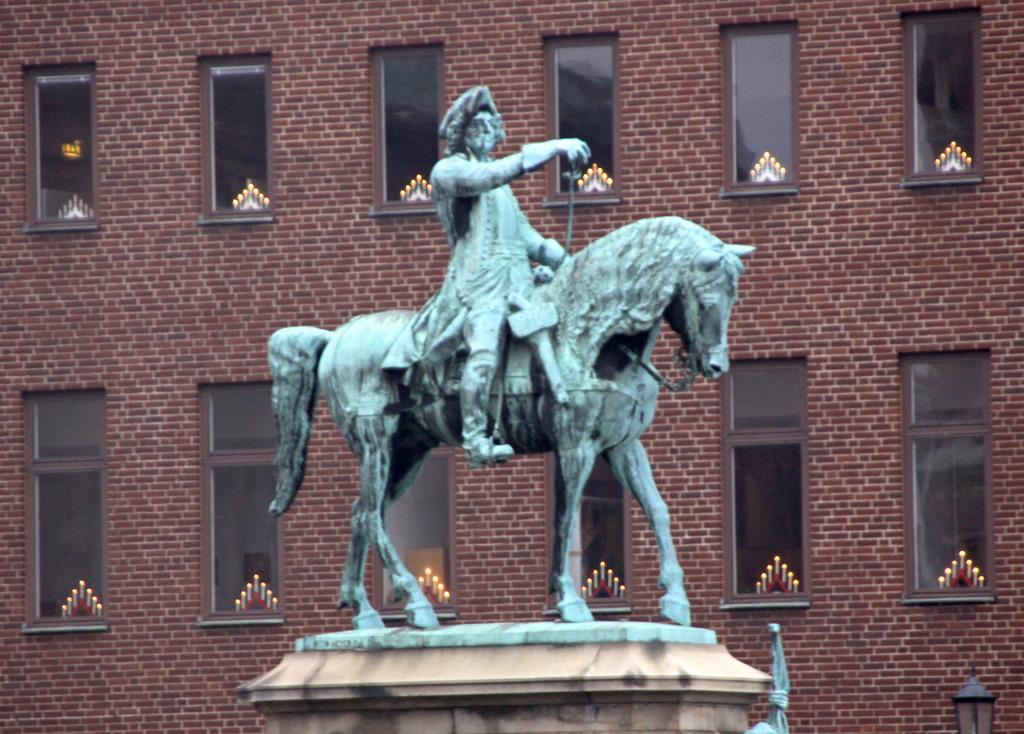What is the main subject in the image? There is a statue in the image. What can be seen in the background of the image? There is a building in the background of the image. What feature of the building is mentioned in the facts? The building has windows. What type of sponge is being used to clean the statue in the image? There is no sponge or cleaning activity depicted in the image; it only shows a statue and a building in the background. 